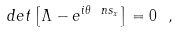Convert formula to latex. <formula><loc_0><loc_0><loc_500><loc_500>d e t \left [ \Lambda - e ^ { i \theta \ n s _ { x } } \right ] = 0 \ ,</formula> 